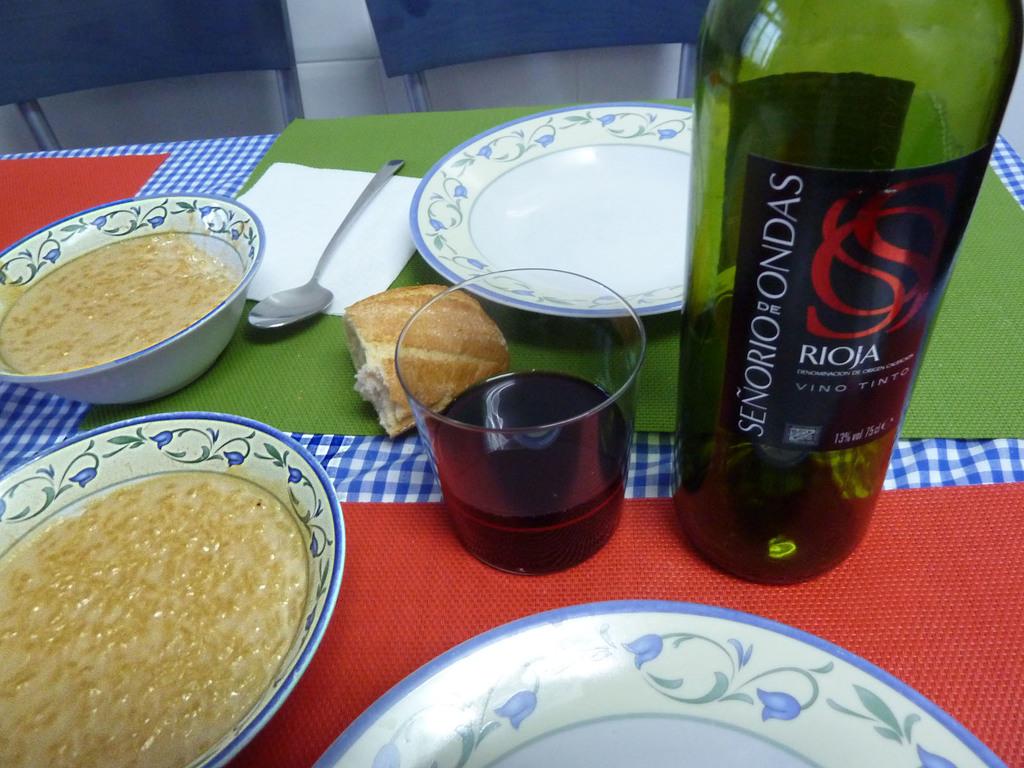What is the name of the drink?
Offer a very short reply. Rioja. What is the type of wine?
Make the answer very short. Rioja. 